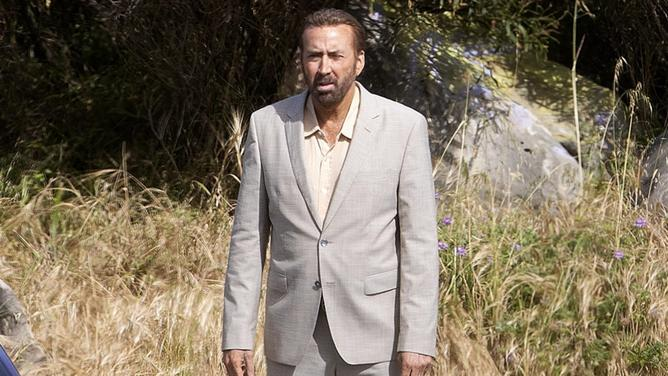Describe the setting where the man is standing. How does it contribute to the overall mood of the image? The man is positioned in a natural landscape with unkempt tall grass and occasional rocky patches, creating a rugged and untamed atmosphere. This setting contributes to a mood of isolation or introspection, enhancing the perceived intensity of the man's expression. The unrefined backdrop may symbolize a return to basics or an encounter with raw realities. 